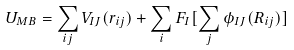Convert formula to latex. <formula><loc_0><loc_0><loc_500><loc_500>U _ { M B } = \sum _ { i j } V _ { I J } ( r _ { i j } ) + \sum _ { i } F _ { I } [ \sum _ { j } \phi _ { I J } ( R _ { i j } ) ]</formula> 